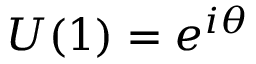Convert formula to latex. <formula><loc_0><loc_0><loc_500><loc_500>U ( 1 ) = e ^ { i \theta }</formula> 